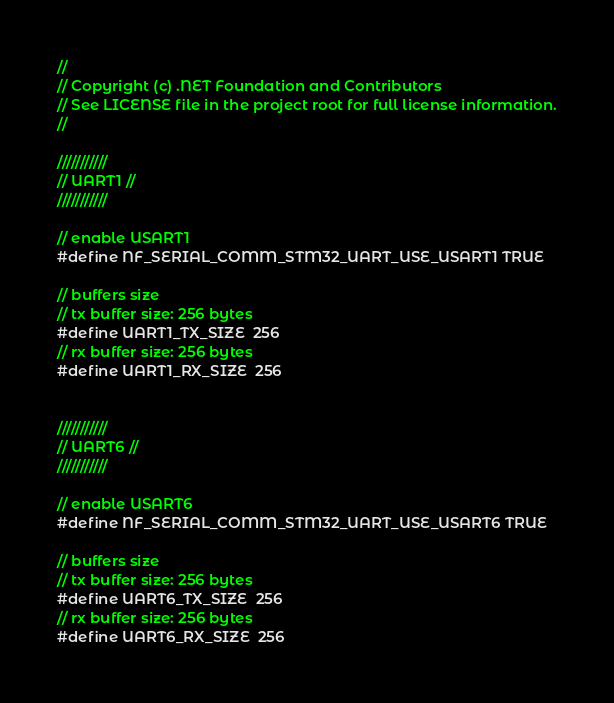Convert code to text. <code><loc_0><loc_0><loc_500><loc_500><_C_>//
// Copyright (c) .NET Foundation and Contributors
// See LICENSE file in the project root for full license information.
//

///////////
// UART1 //
///////////

// enable USART1
#define NF_SERIAL_COMM_STM32_UART_USE_USART1 TRUE

// buffers size
// tx buffer size: 256 bytes
#define UART1_TX_SIZE  256
// rx buffer size: 256 bytes
#define UART1_RX_SIZE  256


///////////
// UART6 //
///////////

// enable USART6
#define NF_SERIAL_COMM_STM32_UART_USE_USART6 TRUE

// buffers size
// tx buffer size: 256 bytes
#define UART6_TX_SIZE  256
// rx buffer size: 256 bytes
#define UART6_RX_SIZE  256
</code> 